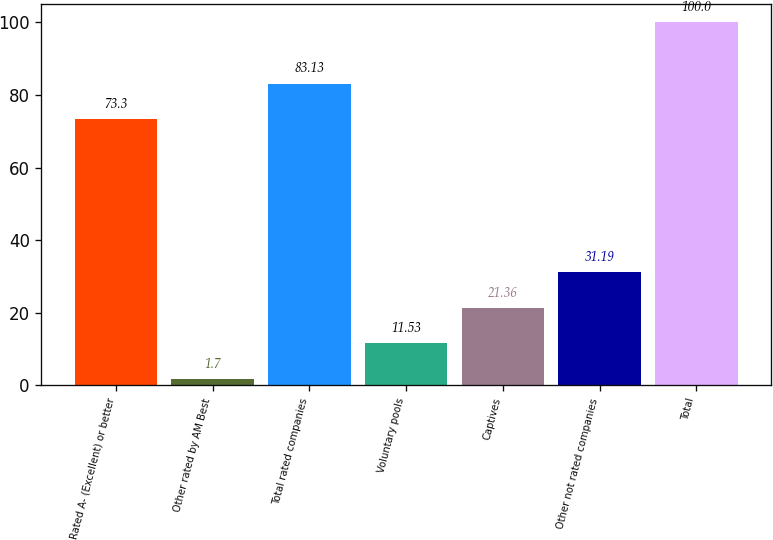Convert chart. <chart><loc_0><loc_0><loc_500><loc_500><bar_chart><fcel>Rated A- (Excellent) or better<fcel>Other rated by AM Best<fcel>Total rated companies<fcel>Voluntary pools<fcel>Captives<fcel>Other not rated companies<fcel>Total<nl><fcel>73.3<fcel>1.7<fcel>83.13<fcel>11.53<fcel>21.36<fcel>31.19<fcel>100<nl></chart> 